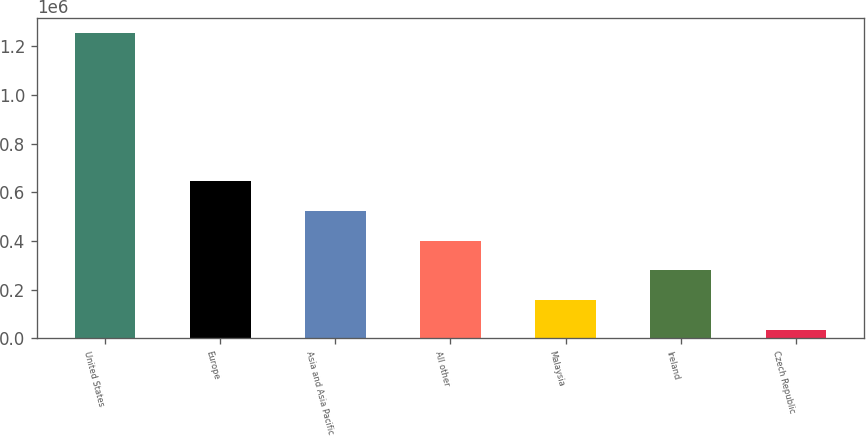Convert chart. <chart><loc_0><loc_0><loc_500><loc_500><bar_chart><fcel>United States<fcel>Europe<fcel>Asia and Asia Pacific<fcel>All other<fcel>Malaysia<fcel>Ireland<fcel>Czech Republic<nl><fcel>1.25482e+06<fcel>645270<fcel>523359<fcel>401448<fcel>157626<fcel>279537<fcel>35715<nl></chart> 